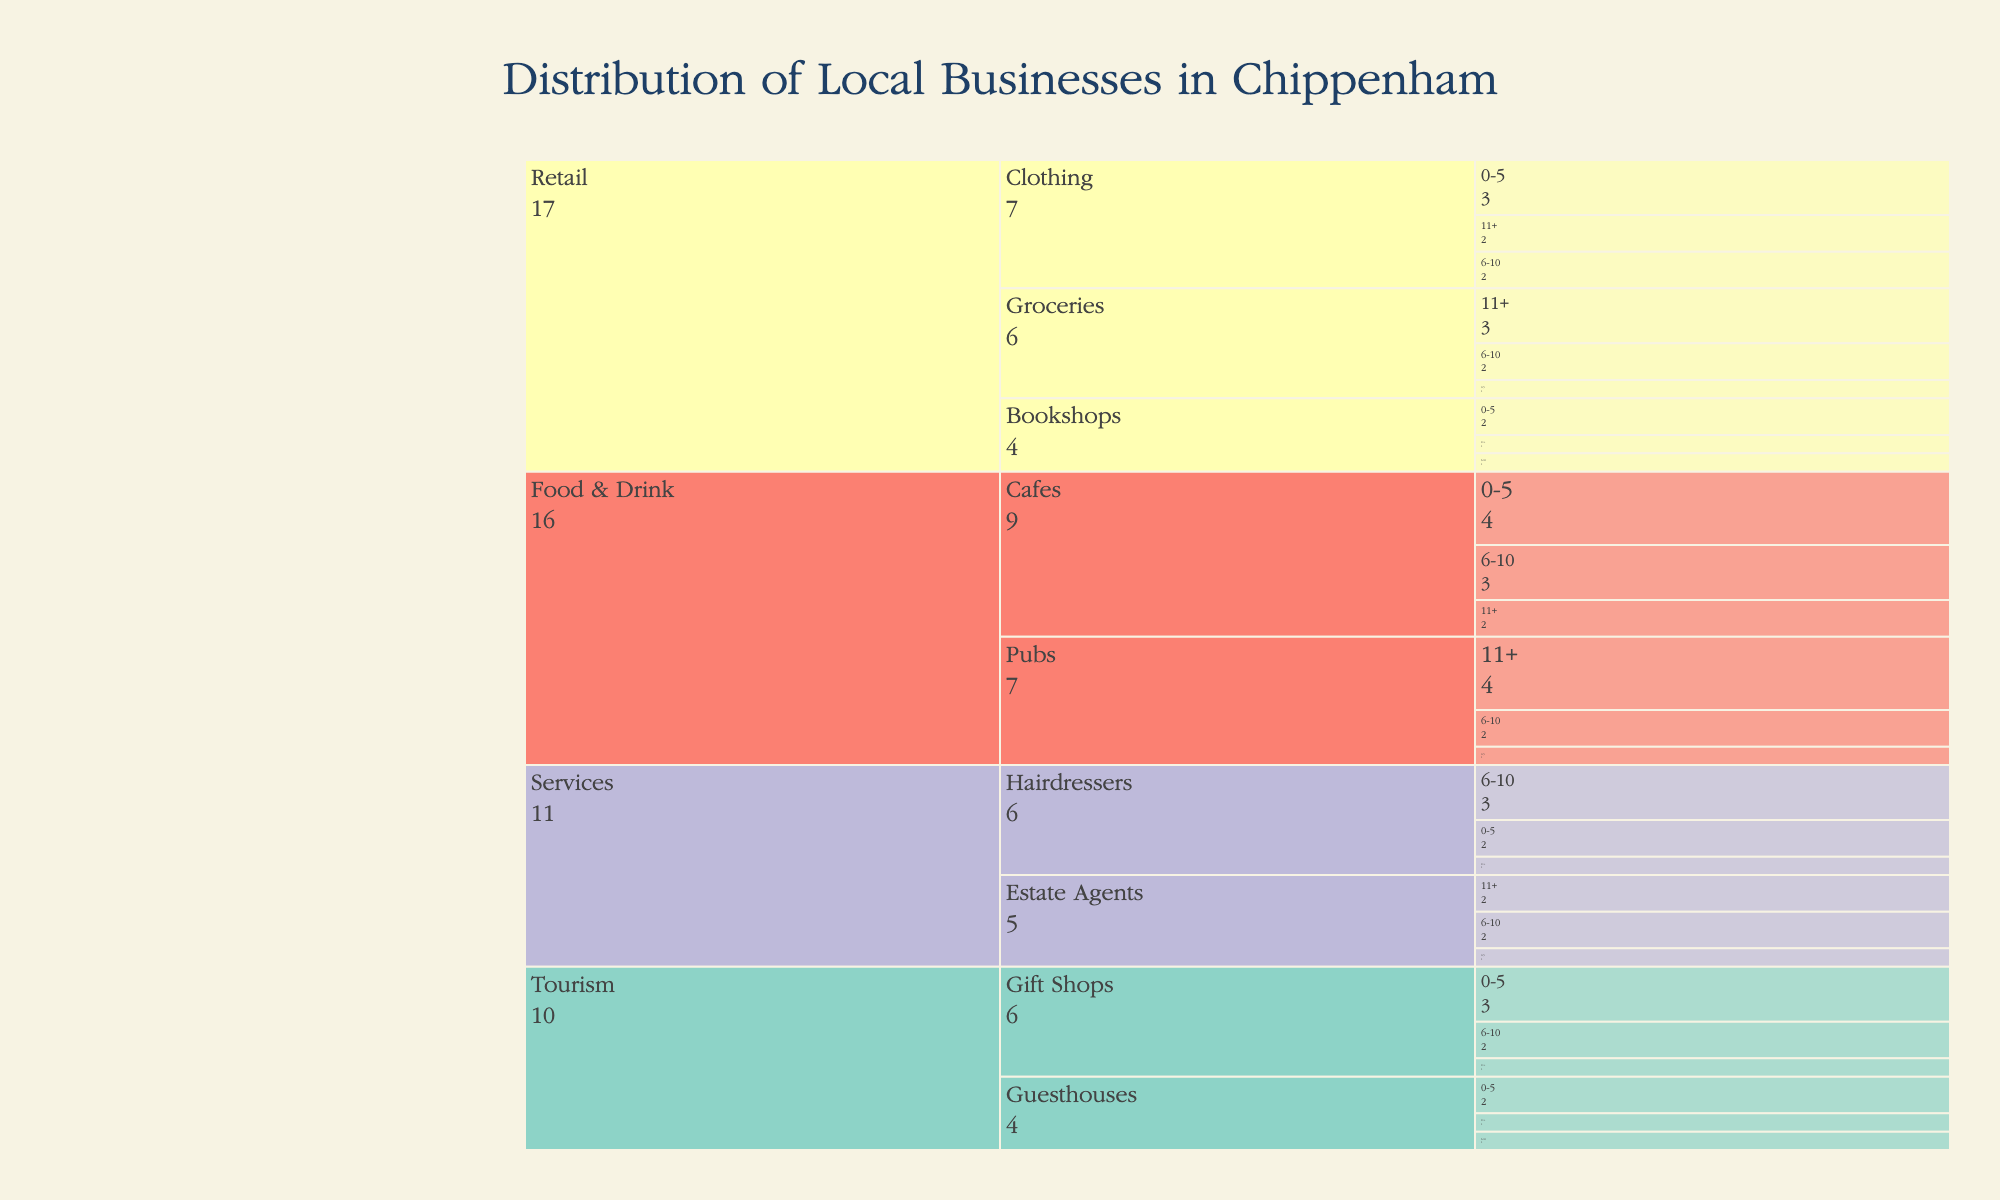What's the title of the figure? The title of the figure is prominently displayed at the top of the chart. It reads "Distribution of Local Businesses in Chippenham".
Answer: Distribution of Local Businesses in Chippenham Which industry sector has the highest number of businesses operating for 11+ years? The figure shows different industry sectors broken down by years of operation. By examining the "11+" years category across all sectors, the Retail sector, specifically Groceries, appears most frequently. This can be seen by noting the number values in the 11+ segments under each sector.
Answer: Retail How many total Bookshops are there in Chippenham? In the chart, we can sum the counts from all the years of operation categories within the Bookshops sector under Retail. We add 2 (0-5 years) + 1 (6-10 years) + 1 (11+ years).
Answer: 4 What is the most common number of years of operation for Cafes? For Cafes, compare the counts across the 0-5, 6-10, and 11+ years categories. The counts are 4 (0-5 years), 3 (6-10 years), and 2 (11+ years).
Answer: 0-5 years Are there more Hairdressers or Estate Agents operating for 6-10 years? For this comparison, check the counts under the 6-10 years category for both Hairdressers and Estate Agents. Hairdressers have a count of 3, while Estate Agents have a count of 2.
Answer: Hairdressers Which industry sector has the least number of businesses that have been operating for 0-5 years? Examine the 0-5 years category across all industry sectors. Pubs under Food & Drink have only 1 business listed.
Answer: Pubs What is the total number of businesses in the Tourism industry that have been operating for 11+ years? Sum the counts for the 11+ years category for both Guesthouses and Gift Shops within the Tourism industry. It's 1 (Guesthouses) + 1 (Gift Shops).
Answer: 2 Compare the number of Clothing businesses to Groceries businesses that have been operating for 6-10 years. Which is higher? Compare the counts in the 6-10 years category for Clothing and Groceries sectors. Clothing has 2, whereas Groceries have 2.
Answer: Equal Which Food & Drink sector has a higher count of businesses operating for 0-5 years, Cafes, or Pubs? In the 0-5 years category, Cafes have 4 businesses, while Pubs have 1.
Answer: Cafes Across all sectors, which years of operation category has the highest number of businesses? Sum the counts for each years of operation category across all sectors. The 0-5 years category appears to have the highest cumulative count.
Answer: 0-5 years 